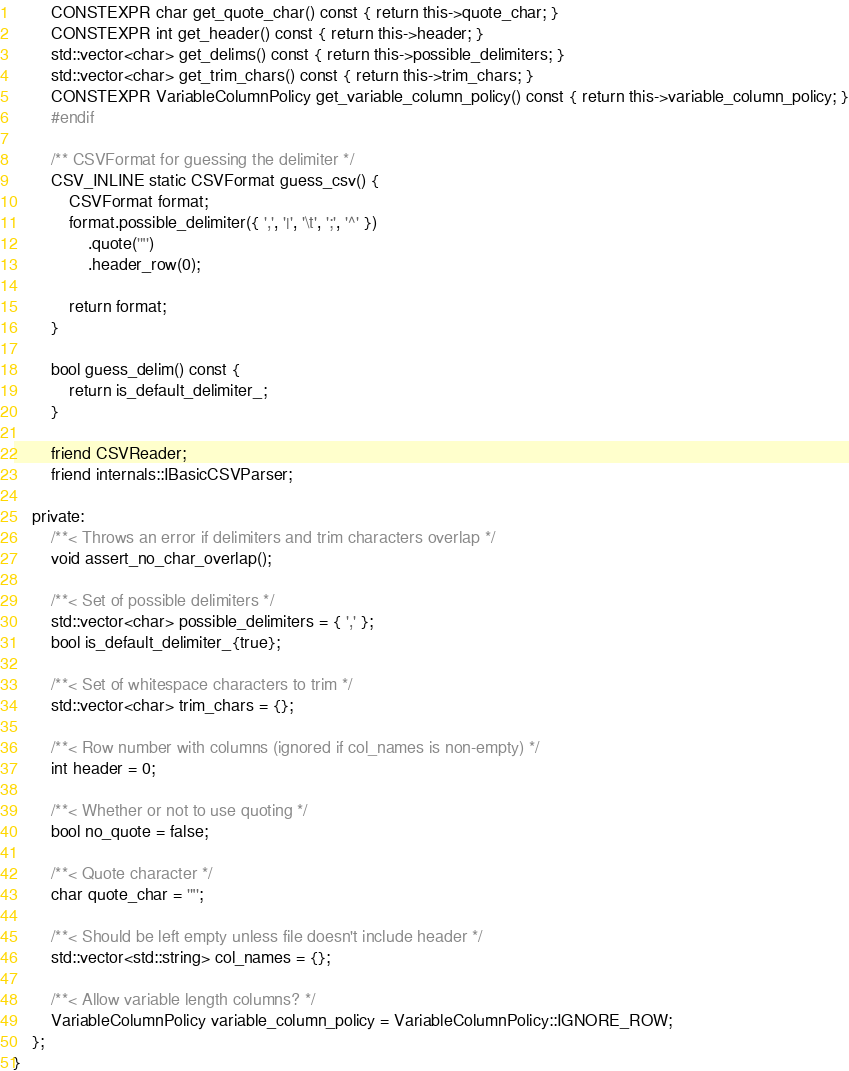Convert code to text. <code><loc_0><loc_0><loc_500><loc_500><_C++_>        CONSTEXPR char get_quote_char() const { return this->quote_char; }
        CONSTEXPR int get_header() const { return this->header; }
        std::vector<char> get_delims() const { return this->possible_delimiters; }
        std::vector<char> get_trim_chars() const { return this->trim_chars; }
        CONSTEXPR VariableColumnPolicy get_variable_column_policy() const { return this->variable_column_policy; }
        #endif

        /** CSVFormat for guessing the delimiter */
        CSV_INLINE static CSVFormat guess_csv() {
            CSVFormat format;
            format.possible_delimiter({ ',', '|', '\t', ';', '^' })
                .quote('"')
                .header_row(0);

            return format;
        }

        bool guess_delim() const {
            return is_default_delimiter_;
        }

        friend CSVReader;
        friend internals::IBasicCSVParser;

    private:
        /**< Throws an error if delimiters and trim characters overlap */
        void assert_no_char_overlap();

        /**< Set of possible delimiters */
        std::vector<char> possible_delimiters = { ',' };
        bool is_default_delimiter_{true};

        /**< Set of whitespace characters to trim */
        std::vector<char> trim_chars = {};

        /**< Row number with columns (ignored if col_names is non-empty) */
        int header = 0;

        /**< Whether or not to use quoting */
        bool no_quote = false;

        /**< Quote character */
        char quote_char = '"';

        /**< Should be left empty unless file doesn't include header */
        std::vector<std::string> col_names = {};

        /**< Allow variable length columns? */
        VariableColumnPolicy variable_column_policy = VariableColumnPolicy::IGNORE_ROW;
    };
}</code> 